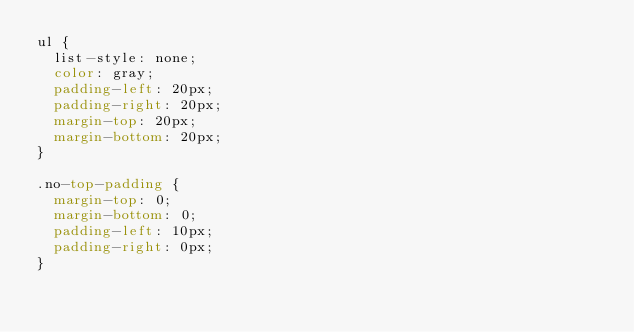Convert code to text. <code><loc_0><loc_0><loc_500><loc_500><_CSS_>ul {
  list-style: none;
  color: gray;
  padding-left: 20px;
  padding-right: 20px;
  margin-top: 20px;
  margin-bottom: 20px;
}

.no-top-padding {
  margin-top: 0;
  margin-bottom: 0;
  padding-left: 10px;
  padding-right: 0px;
}
</code> 